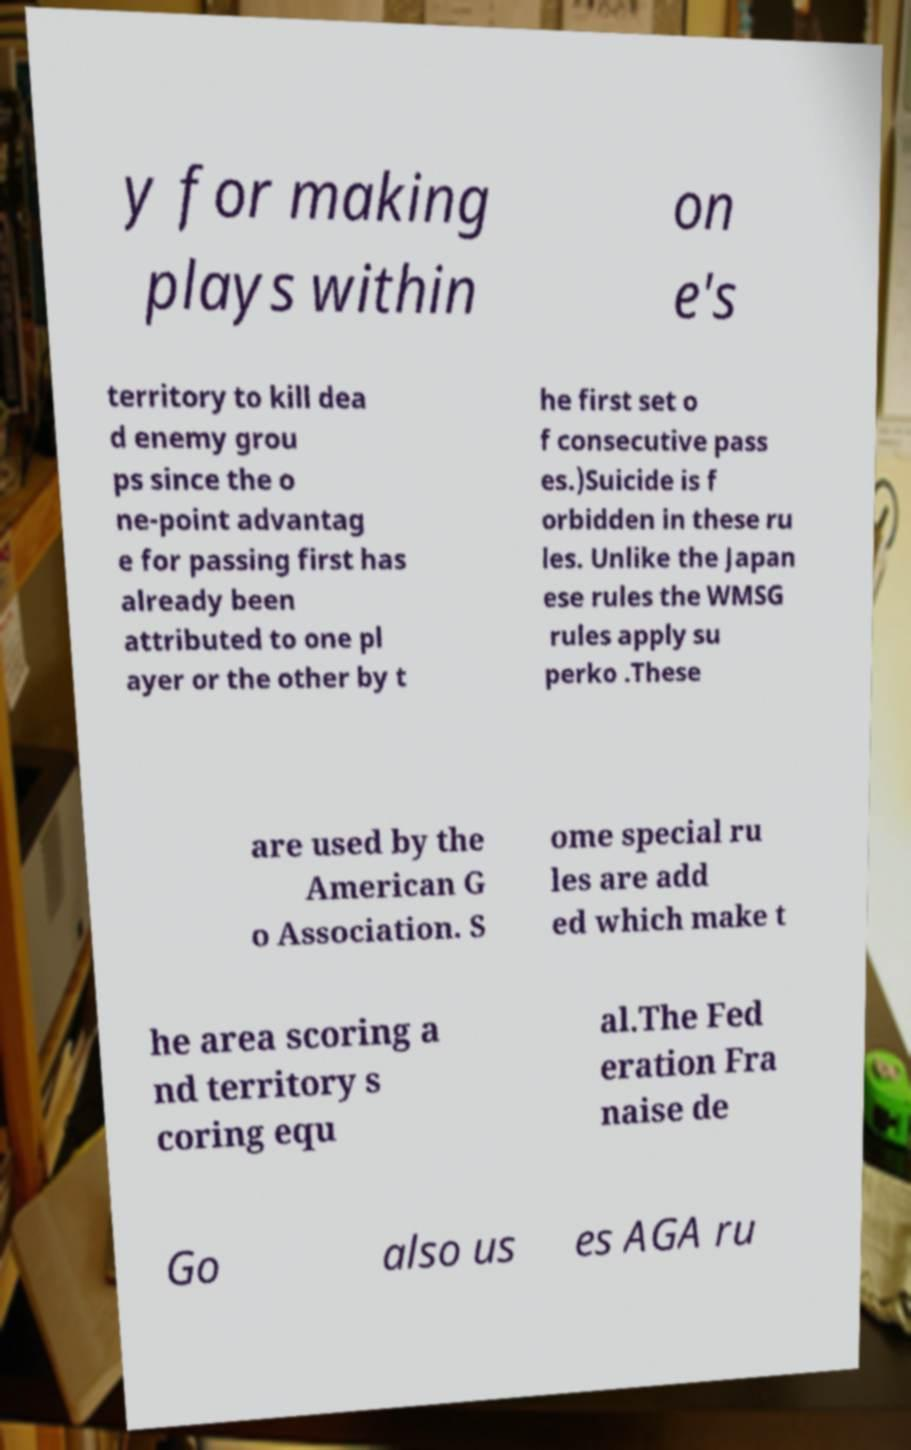Could you extract and type out the text from this image? y for making plays within on e's territory to kill dea d enemy grou ps since the o ne-point advantag e for passing first has already been attributed to one pl ayer or the other by t he first set o f consecutive pass es.)Suicide is f orbidden in these ru les. Unlike the Japan ese rules the WMSG rules apply su perko .These are used by the American G o Association. S ome special ru les are add ed which make t he area scoring a nd territory s coring equ al.The Fed eration Fra naise de Go also us es AGA ru 